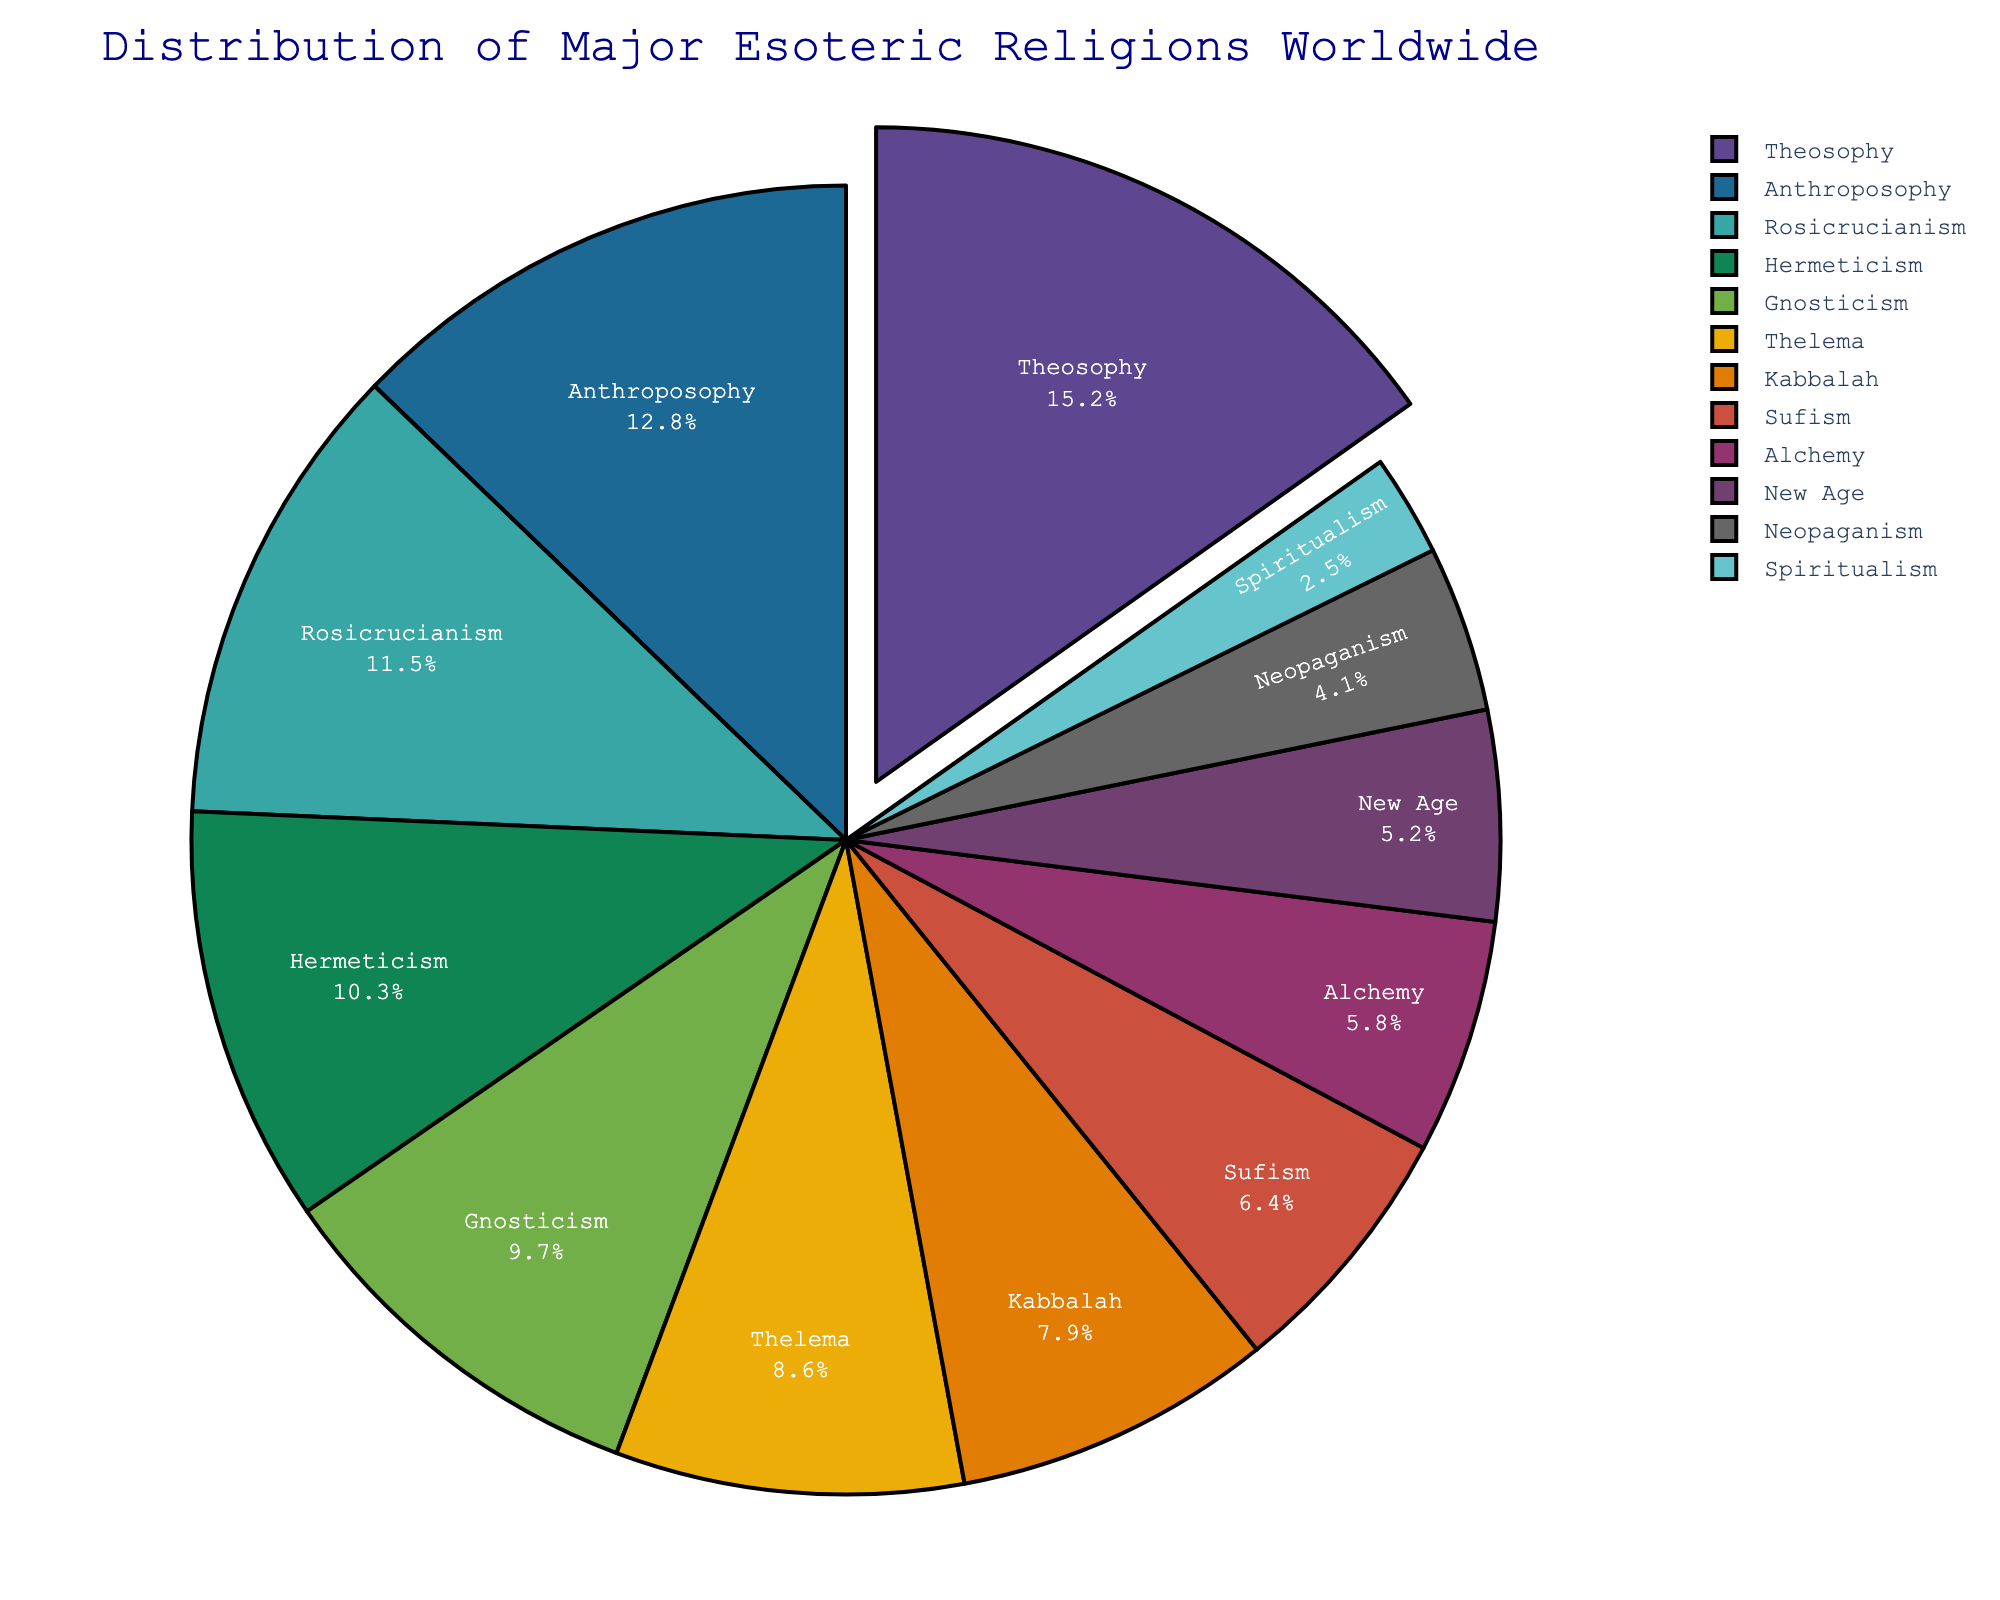What's the largest esoteric religion by percentage? By examining the pie chart, we locate the largest segment of the pie, labeled "Theosophy." The associated percentage shown on this segment is 15.2%, indicating it is the largest.
Answer: Theosophy What's the combined percentage of Theosophy and Anthroposophy? Locate Theosophy (15.2%) and Anthroposophy (12.8%) from the pie chart, then sum these percentages: 15.2% + 12.8% = 28.0%.
Answer: 28.0% Which esoteric religion has a larger percentage, Thelema or Kabbalah? Both Thelema and Kabbalah percentages are displayed on the pie chart. Thelema has 8.6%, while Kabbalah has 7.9%. 8.6% is larger than 7.9%.
Answer: Thelema How many esoteric religions have a percentage higher than 10%? By inspecting each segment of the pie chart, identify the religions with percentages above 10%: Theosophy (15.2%), Anthroposophy (12.8%), Rosicrucianism (11.5%), and Hermeticism (10.3%). There are 4 such religions.
Answer: 4 Which esoteric religion is represented by the green segment in the chart? Identify the green segment from the overall palette used in the pie chart, and read the associated label. Let's assume the green segment corresponds to Sufism.
Answer: Sufism What's the total percentage of all esoteric religions below 5%? Identify all religions with percentages below 5%: Neopaganism (4.1%) and Spiritualism (2.5%), add these values: 4.1% + 2.5% = 6.6%.
Answer: 6.6% How does the percentage of Alchemy compare to Rosicrucianism? Locate both Alchemy (5.8%) and Rosicrucianism (11.5%) on the pie chart; 5.8% is less than 11.5%.
Answer: Alchemy is less than Rosicrucianism What's the difference in percentage between the top two esoteric religions? Identify the top two religions as Theosophy (15.2%) and Anthroposophy (12.8%) and then calculate the difference: 15.2% - 12.8% = 2.4%.
Answer: 2.4% What's the average percentage of Hermeticism, Gnosticism, and Thelema? Sum the percentages: Hermeticism (10.3%), Gnosticism (9.7%), and Thelema (8.6%). Adding them yields 10.3% + 9.7% + 8.6% = 28.6%. Divide by the number of religions: 28.6% / 3 = 9.53%.
Answer: 9.53% 